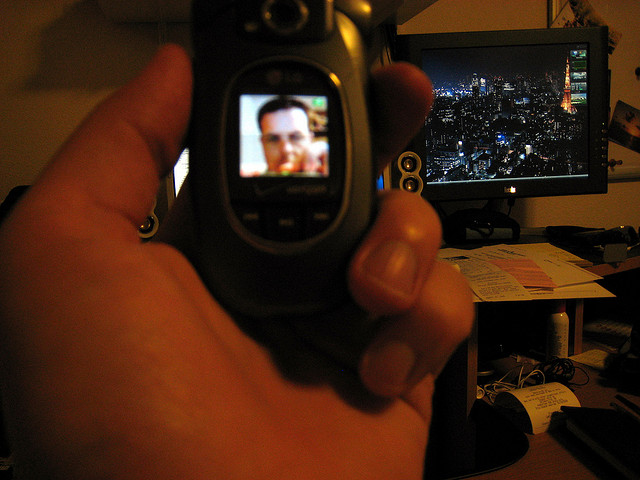<image>What does the hand light represent? It is unknown what the hand light represents. It might be a cell phone or camera. What does the hand light represent? I don't know what the hand light represents. It can be a cell phone, a phone camera, or a camera. 